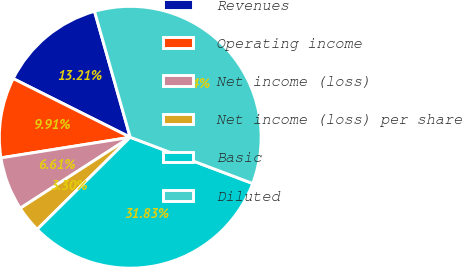Convert chart. <chart><loc_0><loc_0><loc_500><loc_500><pie_chart><fcel>Revenues<fcel>Operating income<fcel>Net income (loss)<fcel>Net income (loss) per share<fcel>Basic<fcel>Diluted<nl><fcel>13.21%<fcel>9.91%<fcel>6.61%<fcel>3.3%<fcel>31.83%<fcel>35.14%<nl></chart> 